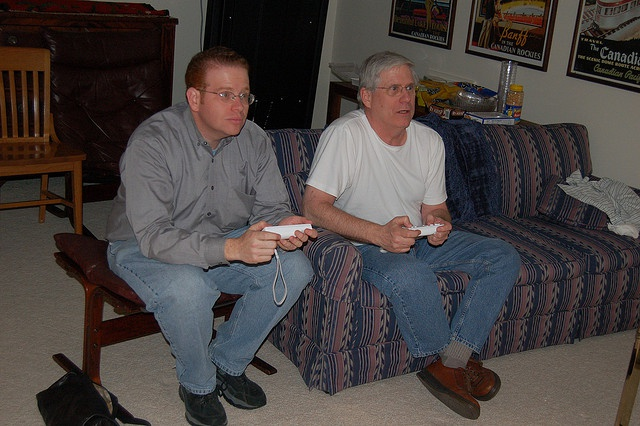Describe the objects in this image and their specific colors. I can see couch in black and gray tones, people in black, gray, and brown tones, people in black, darkgray, blue, gray, and brown tones, chair in black, maroon, and gray tones, and bench in black, gray, and maroon tones in this image. 